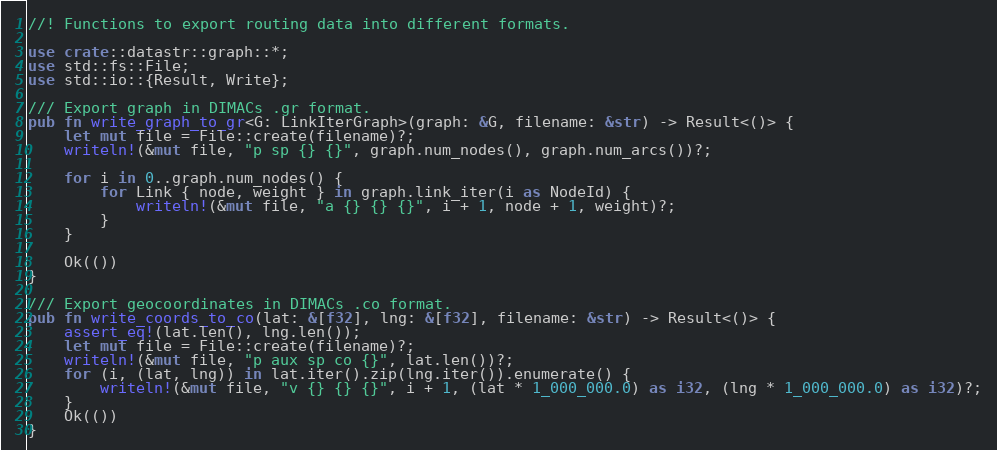<code> <loc_0><loc_0><loc_500><loc_500><_Rust_>//! Functions to export routing data into different formats.

use crate::datastr::graph::*;
use std::fs::File;
use std::io::{Result, Write};

/// Export graph in DIMACs .gr format.
pub fn write_graph_to_gr<G: LinkIterGraph>(graph: &G, filename: &str) -> Result<()> {
    let mut file = File::create(filename)?;
    writeln!(&mut file, "p sp {} {}", graph.num_nodes(), graph.num_arcs())?;

    for i in 0..graph.num_nodes() {
        for Link { node, weight } in graph.link_iter(i as NodeId) {
            writeln!(&mut file, "a {} {} {}", i + 1, node + 1, weight)?;
        }
    }

    Ok(())
}

/// Export geocoordinates in DIMACs .co format.
pub fn write_coords_to_co(lat: &[f32], lng: &[f32], filename: &str) -> Result<()> {
    assert_eq!(lat.len(), lng.len());
    let mut file = File::create(filename)?;
    writeln!(&mut file, "p aux sp co {}", lat.len())?;
    for (i, (lat, lng)) in lat.iter().zip(lng.iter()).enumerate() {
        writeln!(&mut file, "v {} {} {}", i + 1, (lat * 1_000_000.0) as i32, (lng * 1_000_000.0) as i32)?;
    }
    Ok(())
}
</code> 